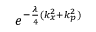<formula> <loc_0><loc_0><loc_500><loc_500>e ^ { - \frac { \lambda } { 4 } ( k _ { x } ^ { 2 } + k _ { p } ^ { 2 } ) }</formula> 